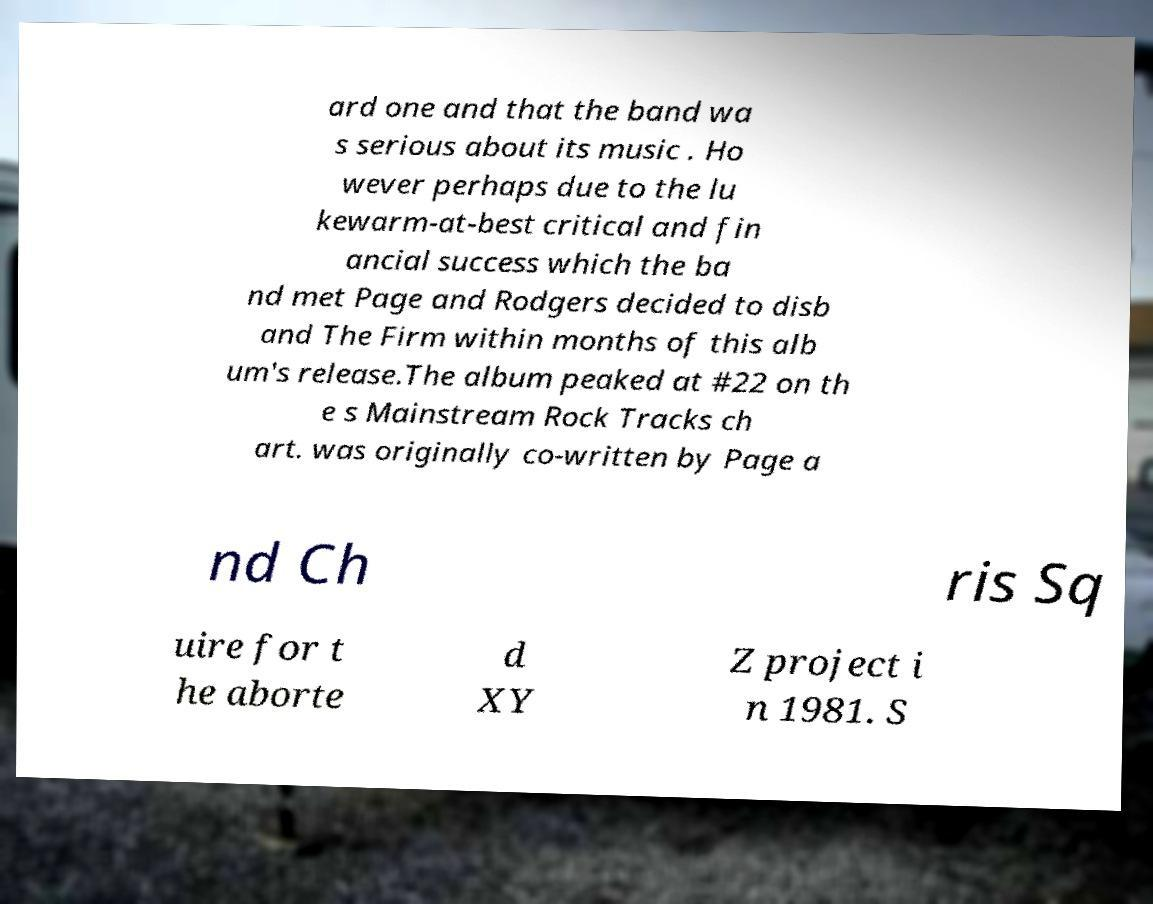Can you read and provide the text displayed in the image?This photo seems to have some interesting text. Can you extract and type it out for me? ard one and that the band wa s serious about its music . Ho wever perhaps due to the lu kewarm-at-best critical and fin ancial success which the ba nd met Page and Rodgers decided to disb and The Firm within months of this alb um's release.The album peaked at #22 on th e s Mainstream Rock Tracks ch art. was originally co-written by Page a nd Ch ris Sq uire for t he aborte d XY Z project i n 1981. S 